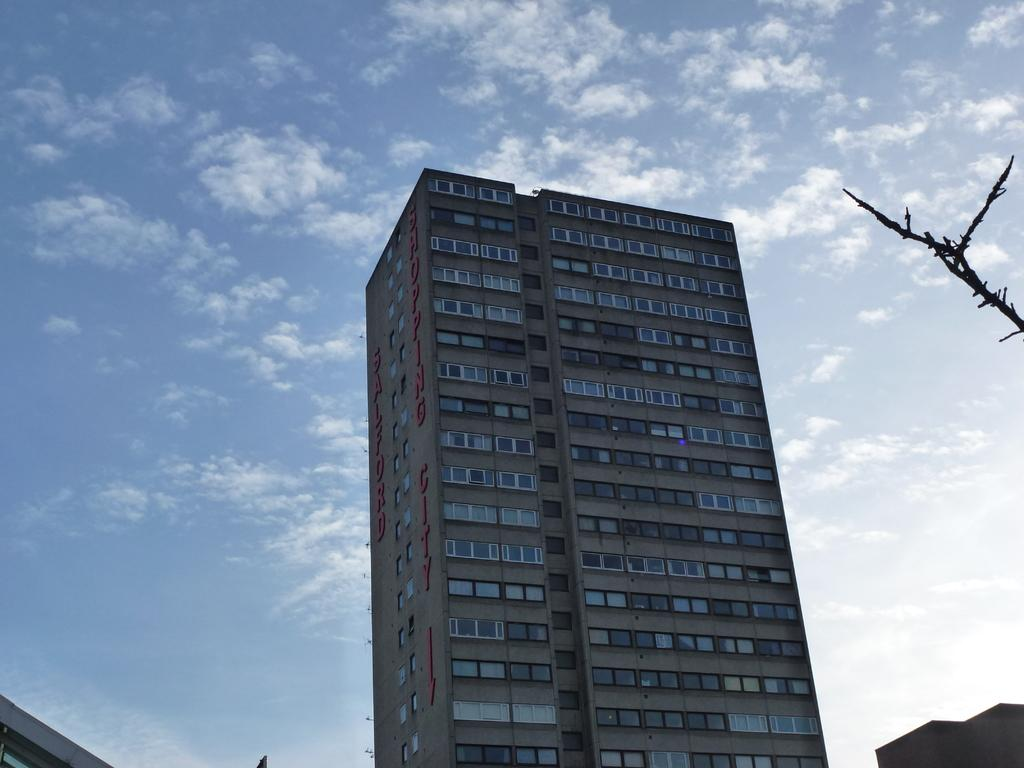What type of structure is present in the image? There is a tall building in the image. What can be seen in the background of the image? There is a sky visible in the background of the image. What is the condition of the sky in the image? There are clouds in the sky. How many rabbits can be seen jumping around the tall building in the image? There are no rabbits present in the image; it only features a tall building and a sky with clouds. 